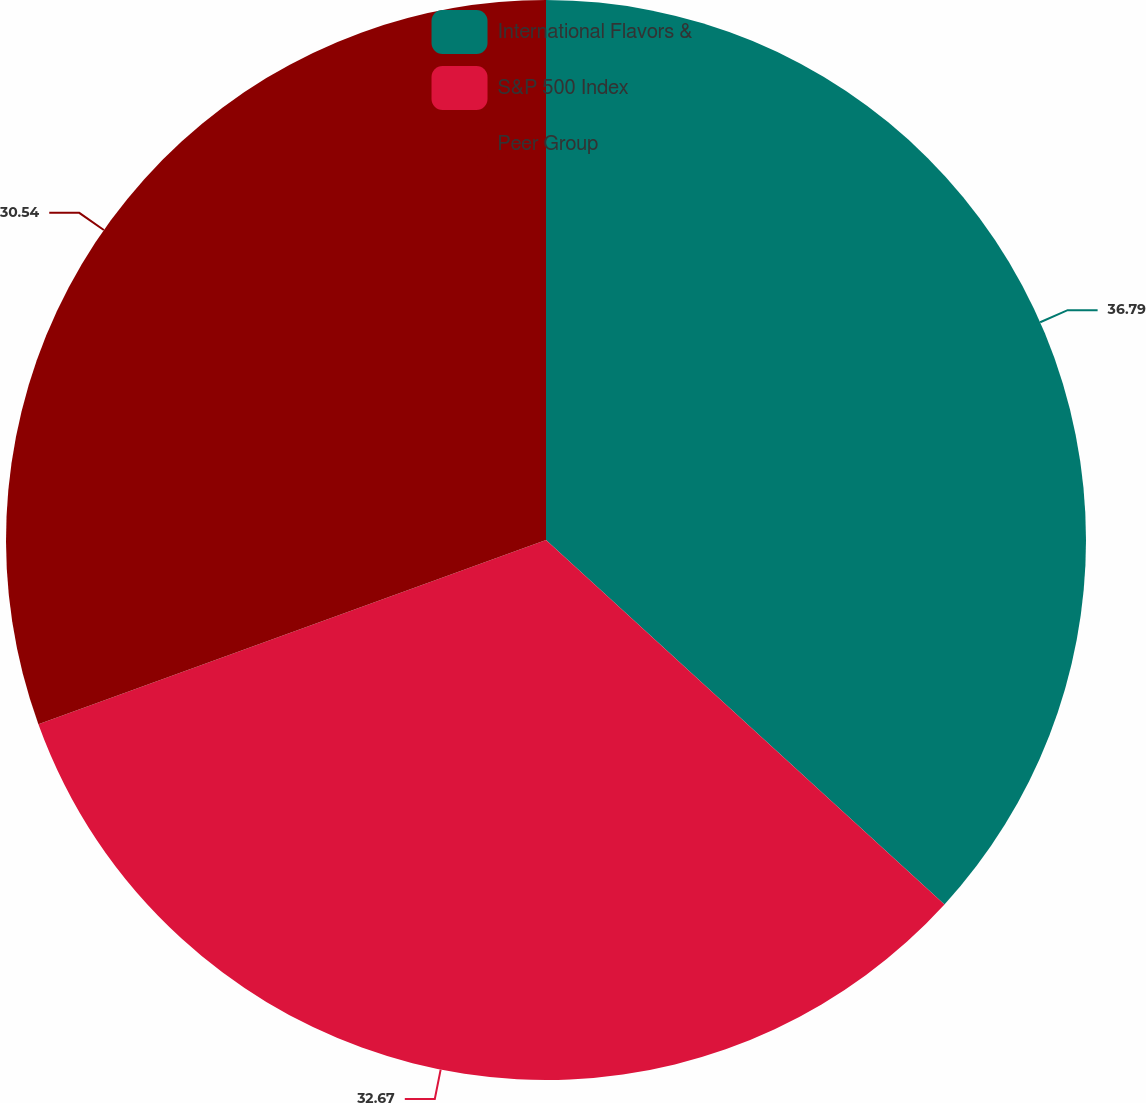Convert chart. <chart><loc_0><loc_0><loc_500><loc_500><pie_chart><fcel>International Flavors &<fcel>S&P 500 Index<fcel>Peer Group<nl><fcel>36.79%<fcel>32.67%<fcel>30.54%<nl></chart> 